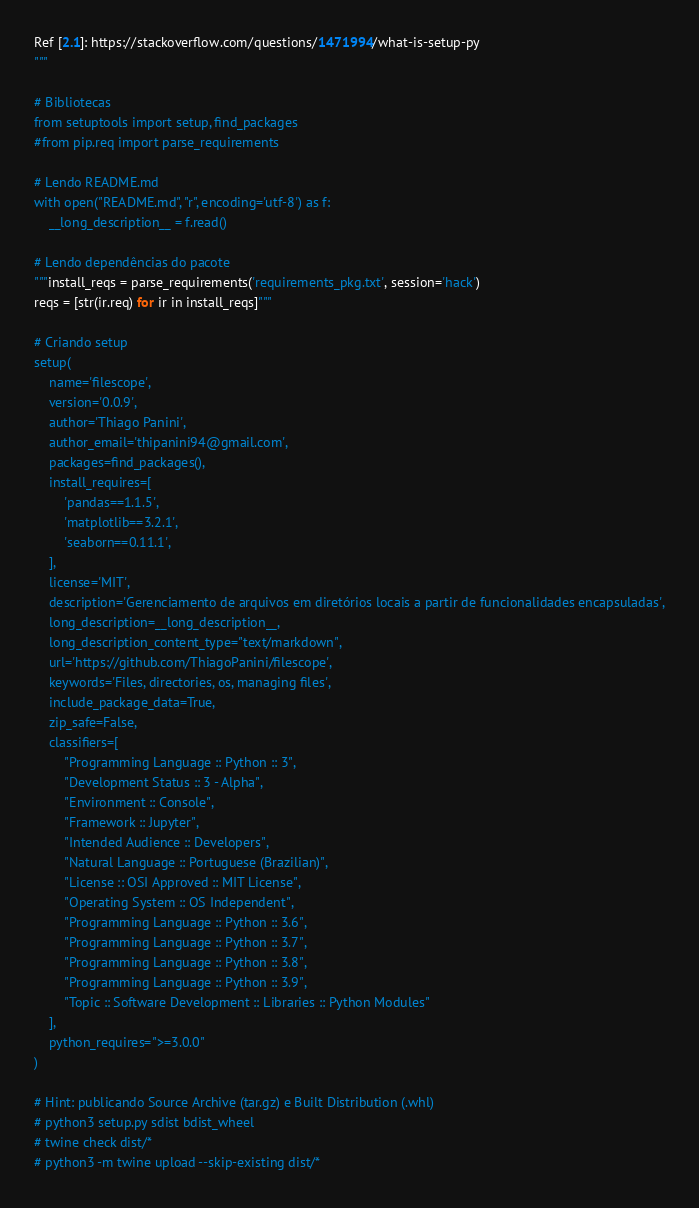Convert code to text. <code><loc_0><loc_0><loc_500><loc_500><_Python_>
Ref [2.1]: https://stackoverflow.com/questions/1471994/what-is-setup-py
"""

# Bibliotecas
from setuptools import setup, find_packages
#from pip.req import parse_requirements

# Lendo README.md
with open("README.md", "r", encoding='utf-8') as f:
    __long_description__ = f.read()

# Lendo dependências do pacote
"""install_reqs = parse_requirements('requirements_pkg.txt', session='hack')
reqs = [str(ir.req) for ir in install_reqs]"""

# Criando setup
setup(
    name='filescope',
    version='0.0.9',
    author='Thiago Panini',
    author_email='thipanini94@gmail.com',
    packages=find_packages(),
    install_requires=[
        'pandas==1.1.5',
        'matplotlib==3.2.1',
        'seaborn==0.11.1',
    ],
    license='MIT',
    description='Gerenciamento de arquivos em diretórios locais a partir de funcionalidades encapsuladas',
    long_description=__long_description__,
    long_description_content_type="text/markdown",
    url='https://github.com/ThiagoPanini/filescope',
    keywords='Files, directories, os, managing files',
    include_package_data=True,
    zip_safe=False,
    classifiers=[
        "Programming Language :: Python :: 3",
        "Development Status :: 3 - Alpha",
        "Environment :: Console",
        "Framework :: Jupyter",
        "Intended Audience :: Developers",
        "Natural Language :: Portuguese (Brazilian)",
        "License :: OSI Approved :: MIT License",
        "Operating System :: OS Independent",
        "Programming Language :: Python :: 3.6",
        "Programming Language :: Python :: 3.7",
        "Programming Language :: Python :: 3.8",
        "Programming Language :: Python :: 3.9",
        "Topic :: Software Development :: Libraries :: Python Modules"
    ],
    python_requires=">=3.0.0"
)

# Hint: publicando Source Archive (tar.gz) e Built Distribution (.whl)
# python3 setup.py sdist bdist_wheel
# twine check dist/*
# python3 -m twine upload --skip-existing dist/*</code> 